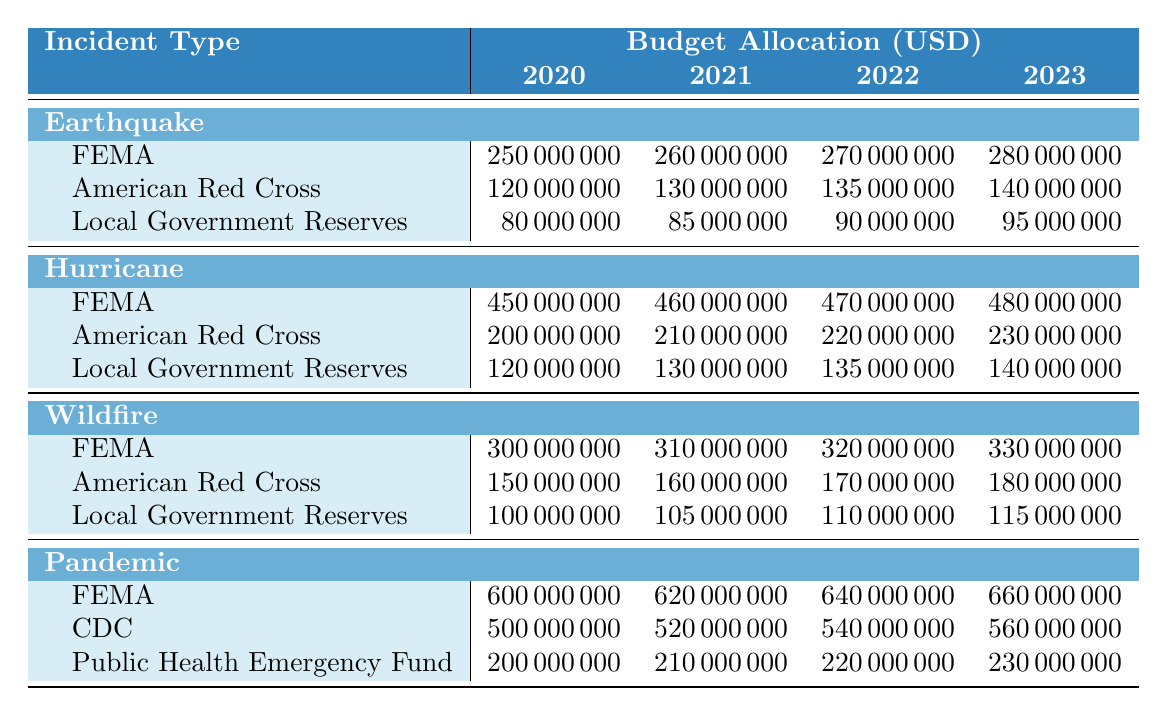What was the budget allocation for FEMA in 2020 for Hurricane relief? According to the table, the budget allocation for FEMA for Hurricane relief in 2020 is listed as 450,000,000 USD.
Answer: 450000000 What is the total budget allocated for Earthquake relief from all sources in 2021? To find the total budget for Earthquake relief in 2021, we sum the contributions from FEMA (260,000,000), American Red Cross (130,000,000), and Local Government Reserves (85,000,000): 260,000,000 + 130,000,000 + 85,000,000 = 475,000,000 USD.
Answer: 475000000 Did the budget allocation from the American Red Cross for Wildfire relief increase every year from 2020 to 2023? By examining the table, the allocations for Wildfire from American Red Cross are: 150,000,000 (2020), 160,000,000 (2021), 170,000,000 (2022), and 180,000,000 (2023), which shows a consistent increase each year. Thus, it is true that the budget increased every year.
Answer: Yes What is the average budget allocated to the CDC for Pandemic relief from 2020 to 2023? The budget allocations for the CDC for Pandemic relief are: 500,000,000 (2020), 520,000,000 (2021), 540,000,000 (2022), and 560,000,000 (2023). First we compute the total: 500,000,000 + 520,000,000 + 540,000,000 + 560,000,000 = 2,120,000,000 USD. Then we divide by the number of years, which is 4: 2,120,000,000 / 4 = 530,000,000 USD.
Answer: 530000000 Which incident type received the highest total budget allocation from FEMA over the years 2020 to 2023? The budget allocations from FEMA for various incident types over the years are as follows: For Earthquake: 250,000,000 + 260,000,000 + 270,000,000 + 280,000,000 = 1,060,000,000; for Hurricane: 450,000,000 + 460,000,000 + 470,000,000 + 480,000,000 = 1,860,000,000; for Wildfire: 300,000,000 + 310,000,000 + 320,000,000 + 330,000,000 = 1,260,000,000; for Pandemic: 600,000,000 + 620,000,000 + 640,000,000 + 660,000,000 = 2,520,000,000. The highest total is from Pandemic with 2,520,000,000 USD.
Answer: Pandemic 